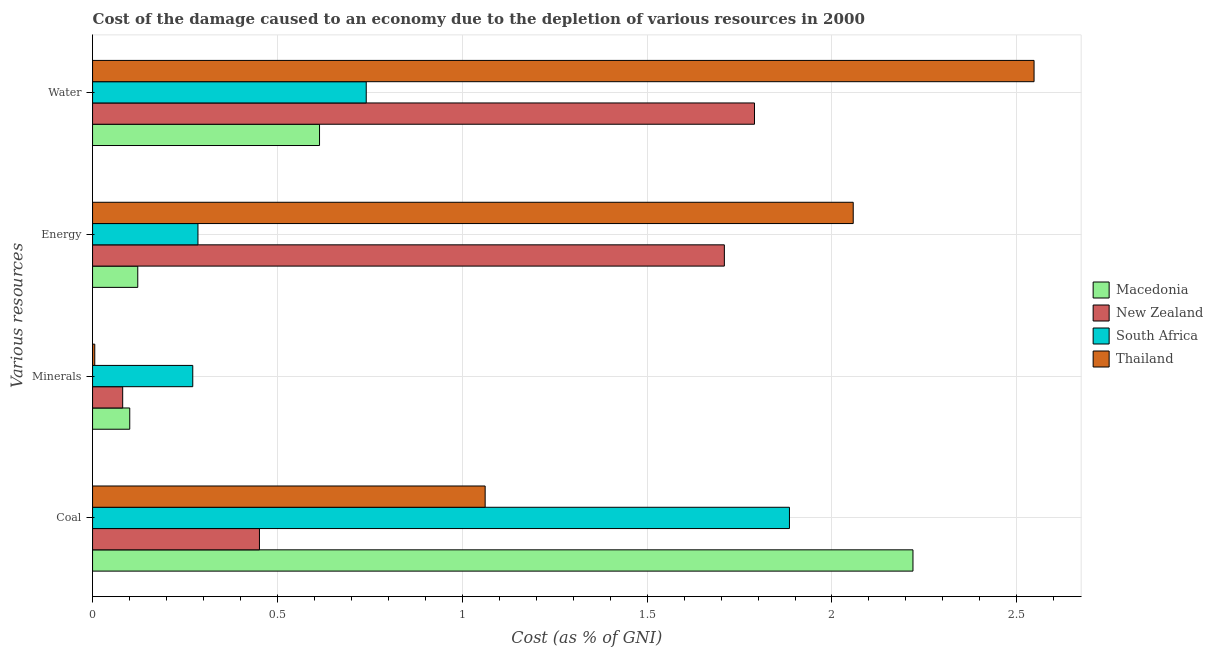Are the number of bars on each tick of the Y-axis equal?
Provide a succinct answer. Yes. How many bars are there on the 2nd tick from the bottom?
Provide a succinct answer. 4. What is the label of the 3rd group of bars from the top?
Give a very brief answer. Minerals. What is the cost of damage due to depletion of coal in New Zealand?
Keep it short and to the point. 0.45. Across all countries, what is the maximum cost of damage due to depletion of water?
Offer a terse response. 2.55. Across all countries, what is the minimum cost of damage due to depletion of energy?
Your response must be concise. 0.12. In which country was the cost of damage due to depletion of coal maximum?
Offer a terse response. Macedonia. In which country was the cost of damage due to depletion of water minimum?
Offer a very short reply. Macedonia. What is the total cost of damage due to depletion of coal in the graph?
Offer a very short reply. 5.62. What is the difference between the cost of damage due to depletion of minerals in Thailand and that in New Zealand?
Offer a very short reply. -0.08. What is the difference between the cost of damage due to depletion of coal in South Africa and the cost of damage due to depletion of energy in Macedonia?
Provide a succinct answer. 1.76. What is the average cost of damage due to depletion of water per country?
Ensure brevity in your answer.  1.42. What is the difference between the cost of damage due to depletion of minerals and cost of damage due to depletion of coal in Thailand?
Ensure brevity in your answer.  -1.06. What is the ratio of the cost of damage due to depletion of minerals in Thailand to that in South Africa?
Offer a terse response. 0.02. Is the cost of damage due to depletion of coal in South Africa less than that in New Zealand?
Provide a short and direct response. No. Is the difference between the cost of damage due to depletion of water in South Africa and Thailand greater than the difference between the cost of damage due to depletion of minerals in South Africa and Thailand?
Your response must be concise. No. What is the difference between the highest and the second highest cost of damage due to depletion of energy?
Offer a very short reply. 0.35. What is the difference between the highest and the lowest cost of damage due to depletion of water?
Offer a terse response. 1.93. In how many countries, is the cost of damage due to depletion of energy greater than the average cost of damage due to depletion of energy taken over all countries?
Offer a very short reply. 2. Is the sum of the cost of damage due to depletion of energy in South Africa and New Zealand greater than the maximum cost of damage due to depletion of minerals across all countries?
Offer a terse response. Yes. What does the 4th bar from the top in Minerals represents?
Give a very brief answer. Macedonia. What does the 4th bar from the bottom in Water represents?
Your answer should be compact. Thailand. Are all the bars in the graph horizontal?
Offer a terse response. Yes. How many countries are there in the graph?
Keep it short and to the point. 4. Are the values on the major ticks of X-axis written in scientific E-notation?
Your response must be concise. No. Does the graph contain grids?
Keep it short and to the point. Yes. How are the legend labels stacked?
Make the answer very short. Vertical. What is the title of the graph?
Your response must be concise. Cost of the damage caused to an economy due to the depletion of various resources in 2000 . What is the label or title of the X-axis?
Give a very brief answer. Cost (as % of GNI). What is the label or title of the Y-axis?
Your answer should be compact. Various resources. What is the Cost (as % of GNI) of Macedonia in Coal?
Ensure brevity in your answer.  2.22. What is the Cost (as % of GNI) of New Zealand in Coal?
Offer a terse response. 0.45. What is the Cost (as % of GNI) in South Africa in Coal?
Your response must be concise. 1.88. What is the Cost (as % of GNI) of Thailand in Coal?
Give a very brief answer. 1.06. What is the Cost (as % of GNI) in Macedonia in Minerals?
Your answer should be very brief. 0.1. What is the Cost (as % of GNI) of New Zealand in Minerals?
Make the answer very short. 0.08. What is the Cost (as % of GNI) in South Africa in Minerals?
Your answer should be very brief. 0.27. What is the Cost (as % of GNI) of Thailand in Minerals?
Give a very brief answer. 0.01. What is the Cost (as % of GNI) in Macedonia in Energy?
Ensure brevity in your answer.  0.12. What is the Cost (as % of GNI) of New Zealand in Energy?
Provide a short and direct response. 1.71. What is the Cost (as % of GNI) of South Africa in Energy?
Keep it short and to the point. 0.29. What is the Cost (as % of GNI) in Thailand in Energy?
Provide a short and direct response. 2.06. What is the Cost (as % of GNI) in Macedonia in Water?
Ensure brevity in your answer.  0.61. What is the Cost (as % of GNI) in New Zealand in Water?
Ensure brevity in your answer.  1.79. What is the Cost (as % of GNI) in South Africa in Water?
Provide a short and direct response. 0.74. What is the Cost (as % of GNI) in Thailand in Water?
Offer a very short reply. 2.55. Across all Various resources, what is the maximum Cost (as % of GNI) in Macedonia?
Provide a short and direct response. 2.22. Across all Various resources, what is the maximum Cost (as % of GNI) in New Zealand?
Make the answer very short. 1.79. Across all Various resources, what is the maximum Cost (as % of GNI) of South Africa?
Your answer should be compact. 1.88. Across all Various resources, what is the maximum Cost (as % of GNI) in Thailand?
Give a very brief answer. 2.55. Across all Various resources, what is the minimum Cost (as % of GNI) of Macedonia?
Give a very brief answer. 0.1. Across all Various resources, what is the minimum Cost (as % of GNI) of New Zealand?
Offer a terse response. 0.08. Across all Various resources, what is the minimum Cost (as % of GNI) of South Africa?
Keep it short and to the point. 0.27. Across all Various resources, what is the minimum Cost (as % of GNI) in Thailand?
Offer a terse response. 0.01. What is the total Cost (as % of GNI) of Macedonia in the graph?
Make the answer very short. 3.06. What is the total Cost (as % of GNI) of New Zealand in the graph?
Offer a terse response. 4.03. What is the total Cost (as % of GNI) of South Africa in the graph?
Keep it short and to the point. 3.18. What is the total Cost (as % of GNI) in Thailand in the graph?
Your answer should be compact. 5.67. What is the difference between the Cost (as % of GNI) of Macedonia in Coal and that in Minerals?
Your response must be concise. 2.12. What is the difference between the Cost (as % of GNI) of New Zealand in Coal and that in Minerals?
Give a very brief answer. 0.37. What is the difference between the Cost (as % of GNI) in South Africa in Coal and that in Minerals?
Your answer should be very brief. 1.61. What is the difference between the Cost (as % of GNI) in Thailand in Coal and that in Minerals?
Give a very brief answer. 1.06. What is the difference between the Cost (as % of GNI) in Macedonia in Coal and that in Energy?
Your answer should be very brief. 2.1. What is the difference between the Cost (as % of GNI) in New Zealand in Coal and that in Energy?
Offer a very short reply. -1.26. What is the difference between the Cost (as % of GNI) of South Africa in Coal and that in Energy?
Provide a short and direct response. 1.6. What is the difference between the Cost (as % of GNI) in Thailand in Coal and that in Energy?
Keep it short and to the point. -1. What is the difference between the Cost (as % of GNI) in Macedonia in Coal and that in Water?
Your answer should be compact. 1.61. What is the difference between the Cost (as % of GNI) in New Zealand in Coal and that in Water?
Offer a terse response. -1.34. What is the difference between the Cost (as % of GNI) in South Africa in Coal and that in Water?
Your response must be concise. 1.14. What is the difference between the Cost (as % of GNI) in Thailand in Coal and that in Water?
Offer a terse response. -1.48. What is the difference between the Cost (as % of GNI) of Macedonia in Minerals and that in Energy?
Your answer should be very brief. -0.02. What is the difference between the Cost (as % of GNI) in New Zealand in Minerals and that in Energy?
Offer a very short reply. -1.63. What is the difference between the Cost (as % of GNI) of South Africa in Minerals and that in Energy?
Ensure brevity in your answer.  -0.01. What is the difference between the Cost (as % of GNI) of Thailand in Minerals and that in Energy?
Your answer should be very brief. -2.05. What is the difference between the Cost (as % of GNI) in Macedonia in Minerals and that in Water?
Offer a very short reply. -0.51. What is the difference between the Cost (as % of GNI) in New Zealand in Minerals and that in Water?
Your answer should be compact. -1.71. What is the difference between the Cost (as % of GNI) of South Africa in Minerals and that in Water?
Offer a terse response. -0.47. What is the difference between the Cost (as % of GNI) in Thailand in Minerals and that in Water?
Offer a terse response. -2.54. What is the difference between the Cost (as % of GNI) of Macedonia in Energy and that in Water?
Offer a terse response. -0.49. What is the difference between the Cost (as % of GNI) in New Zealand in Energy and that in Water?
Offer a terse response. -0.08. What is the difference between the Cost (as % of GNI) in South Africa in Energy and that in Water?
Provide a short and direct response. -0.46. What is the difference between the Cost (as % of GNI) of Thailand in Energy and that in Water?
Make the answer very short. -0.49. What is the difference between the Cost (as % of GNI) in Macedonia in Coal and the Cost (as % of GNI) in New Zealand in Minerals?
Provide a succinct answer. 2.14. What is the difference between the Cost (as % of GNI) in Macedonia in Coal and the Cost (as % of GNI) in South Africa in Minerals?
Your answer should be very brief. 1.95. What is the difference between the Cost (as % of GNI) of Macedonia in Coal and the Cost (as % of GNI) of Thailand in Minerals?
Your answer should be compact. 2.21. What is the difference between the Cost (as % of GNI) in New Zealand in Coal and the Cost (as % of GNI) in South Africa in Minerals?
Offer a terse response. 0.18. What is the difference between the Cost (as % of GNI) in New Zealand in Coal and the Cost (as % of GNI) in Thailand in Minerals?
Your answer should be very brief. 0.45. What is the difference between the Cost (as % of GNI) of South Africa in Coal and the Cost (as % of GNI) of Thailand in Minerals?
Provide a short and direct response. 1.88. What is the difference between the Cost (as % of GNI) of Macedonia in Coal and the Cost (as % of GNI) of New Zealand in Energy?
Keep it short and to the point. 0.51. What is the difference between the Cost (as % of GNI) of Macedonia in Coal and the Cost (as % of GNI) of South Africa in Energy?
Make the answer very short. 1.93. What is the difference between the Cost (as % of GNI) in Macedonia in Coal and the Cost (as % of GNI) in Thailand in Energy?
Keep it short and to the point. 0.16. What is the difference between the Cost (as % of GNI) in New Zealand in Coal and the Cost (as % of GNI) in South Africa in Energy?
Give a very brief answer. 0.17. What is the difference between the Cost (as % of GNI) in New Zealand in Coal and the Cost (as % of GNI) in Thailand in Energy?
Make the answer very short. -1.61. What is the difference between the Cost (as % of GNI) of South Africa in Coal and the Cost (as % of GNI) of Thailand in Energy?
Offer a terse response. -0.17. What is the difference between the Cost (as % of GNI) in Macedonia in Coal and the Cost (as % of GNI) in New Zealand in Water?
Your answer should be compact. 0.43. What is the difference between the Cost (as % of GNI) in Macedonia in Coal and the Cost (as % of GNI) in South Africa in Water?
Ensure brevity in your answer.  1.48. What is the difference between the Cost (as % of GNI) in Macedonia in Coal and the Cost (as % of GNI) in Thailand in Water?
Your response must be concise. -0.33. What is the difference between the Cost (as % of GNI) of New Zealand in Coal and the Cost (as % of GNI) of South Africa in Water?
Provide a succinct answer. -0.29. What is the difference between the Cost (as % of GNI) in New Zealand in Coal and the Cost (as % of GNI) in Thailand in Water?
Your response must be concise. -2.1. What is the difference between the Cost (as % of GNI) in South Africa in Coal and the Cost (as % of GNI) in Thailand in Water?
Provide a short and direct response. -0.66. What is the difference between the Cost (as % of GNI) of Macedonia in Minerals and the Cost (as % of GNI) of New Zealand in Energy?
Your answer should be very brief. -1.61. What is the difference between the Cost (as % of GNI) of Macedonia in Minerals and the Cost (as % of GNI) of South Africa in Energy?
Offer a very short reply. -0.18. What is the difference between the Cost (as % of GNI) of Macedonia in Minerals and the Cost (as % of GNI) of Thailand in Energy?
Your response must be concise. -1.96. What is the difference between the Cost (as % of GNI) in New Zealand in Minerals and the Cost (as % of GNI) in South Africa in Energy?
Your response must be concise. -0.2. What is the difference between the Cost (as % of GNI) in New Zealand in Minerals and the Cost (as % of GNI) in Thailand in Energy?
Your answer should be compact. -1.98. What is the difference between the Cost (as % of GNI) of South Africa in Minerals and the Cost (as % of GNI) of Thailand in Energy?
Make the answer very short. -1.79. What is the difference between the Cost (as % of GNI) in Macedonia in Minerals and the Cost (as % of GNI) in New Zealand in Water?
Keep it short and to the point. -1.69. What is the difference between the Cost (as % of GNI) in Macedonia in Minerals and the Cost (as % of GNI) in South Africa in Water?
Keep it short and to the point. -0.64. What is the difference between the Cost (as % of GNI) of Macedonia in Minerals and the Cost (as % of GNI) of Thailand in Water?
Provide a short and direct response. -2.45. What is the difference between the Cost (as % of GNI) of New Zealand in Minerals and the Cost (as % of GNI) of South Africa in Water?
Keep it short and to the point. -0.66. What is the difference between the Cost (as % of GNI) of New Zealand in Minerals and the Cost (as % of GNI) of Thailand in Water?
Make the answer very short. -2.47. What is the difference between the Cost (as % of GNI) of South Africa in Minerals and the Cost (as % of GNI) of Thailand in Water?
Your response must be concise. -2.28. What is the difference between the Cost (as % of GNI) in Macedonia in Energy and the Cost (as % of GNI) in New Zealand in Water?
Offer a terse response. -1.67. What is the difference between the Cost (as % of GNI) of Macedonia in Energy and the Cost (as % of GNI) of South Africa in Water?
Provide a short and direct response. -0.62. What is the difference between the Cost (as % of GNI) of Macedonia in Energy and the Cost (as % of GNI) of Thailand in Water?
Your response must be concise. -2.42. What is the difference between the Cost (as % of GNI) in New Zealand in Energy and the Cost (as % of GNI) in South Africa in Water?
Offer a terse response. 0.97. What is the difference between the Cost (as % of GNI) in New Zealand in Energy and the Cost (as % of GNI) in Thailand in Water?
Your answer should be very brief. -0.84. What is the difference between the Cost (as % of GNI) of South Africa in Energy and the Cost (as % of GNI) of Thailand in Water?
Offer a terse response. -2.26. What is the average Cost (as % of GNI) in Macedonia per Various resources?
Your answer should be very brief. 0.76. What is the average Cost (as % of GNI) of New Zealand per Various resources?
Offer a terse response. 1.01. What is the average Cost (as % of GNI) of South Africa per Various resources?
Give a very brief answer. 0.8. What is the average Cost (as % of GNI) in Thailand per Various resources?
Ensure brevity in your answer.  1.42. What is the difference between the Cost (as % of GNI) in Macedonia and Cost (as % of GNI) in New Zealand in Coal?
Provide a short and direct response. 1.77. What is the difference between the Cost (as % of GNI) of Macedonia and Cost (as % of GNI) of South Africa in Coal?
Make the answer very short. 0.33. What is the difference between the Cost (as % of GNI) in Macedonia and Cost (as % of GNI) in Thailand in Coal?
Give a very brief answer. 1.16. What is the difference between the Cost (as % of GNI) in New Zealand and Cost (as % of GNI) in South Africa in Coal?
Make the answer very short. -1.43. What is the difference between the Cost (as % of GNI) of New Zealand and Cost (as % of GNI) of Thailand in Coal?
Give a very brief answer. -0.61. What is the difference between the Cost (as % of GNI) of South Africa and Cost (as % of GNI) of Thailand in Coal?
Offer a very short reply. 0.82. What is the difference between the Cost (as % of GNI) in Macedonia and Cost (as % of GNI) in New Zealand in Minerals?
Ensure brevity in your answer.  0.02. What is the difference between the Cost (as % of GNI) of Macedonia and Cost (as % of GNI) of South Africa in Minerals?
Offer a very short reply. -0.17. What is the difference between the Cost (as % of GNI) in Macedonia and Cost (as % of GNI) in Thailand in Minerals?
Give a very brief answer. 0.09. What is the difference between the Cost (as % of GNI) in New Zealand and Cost (as % of GNI) in South Africa in Minerals?
Make the answer very short. -0.19. What is the difference between the Cost (as % of GNI) of New Zealand and Cost (as % of GNI) of Thailand in Minerals?
Provide a short and direct response. 0.08. What is the difference between the Cost (as % of GNI) of South Africa and Cost (as % of GNI) of Thailand in Minerals?
Your answer should be very brief. 0.27. What is the difference between the Cost (as % of GNI) in Macedonia and Cost (as % of GNI) in New Zealand in Energy?
Provide a succinct answer. -1.59. What is the difference between the Cost (as % of GNI) in Macedonia and Cost (as % of GNI) in South Africa in Energy?
Your response must be concise. -0.16. What is the difference between the Cost (as % of GNI) of Macedonia and Cost (as % of GNI) of Thailand in Energy?
Your response must be concise. -1.94. What is the difference between the Cost (as % of GNI) in New Zealand and Cost (as % of GNI) in South Africa in Energy?
Keep it short and to the point. 1.42. What is the difference between the Cost (as % of GNI) in New Zealand and Cost (as % of GNI) in Thailand in Energy?
Provide a succinct answer. -0.35. What is the difference between the Cost (as % of GNI) of South Africa and Cost (as % of GNI) of Thailand in Energy?
Keep it short and to the point. -1.77. What is the difference between the Cost (as % of GNI) in Macedonia and Cost (as % of GNI) in New Zealand in Water?
Your answer should be very brief. -1.18. What is the difference between the Cost (as % of GNI) of Macedonia and Cost (as % of GNI) of South Africa in Water?
Your answer should be compact. -0.13. What is the difference between the Cost (as % of GNI) in Macedonia and Cost (as % of GNI) in Thailand in Water?
Offer a terse response. -1.93. What is the difference between the Cost (as % of GNI) in New Zealand and Cost (as % of GNI) in South Africa in Water?
Provide a short and direct response. 1.05. What is the difference between the Cost (as % of GNI) of New Zealand and Cost (as % of GNI) of Thailand in Water?
Your answer should be compact. -0.76. What is the difference between the Cost (as % of GNI) of South Africa and Cost (as % of GNI) of Thailand in Water?
Provide a short and direct response. -1.81. What is the ratio of the Cost (as % of GNI) of Macedonia in Coal to that in Minerals?
Give a very brief answer. 22.06. What is the ratio of the Cost (as % of GNI) of New Zealand in Coal to that in Minerals?
Your answer should be very brief. 5.54. What is the ratio of the Cost (as % of GNI) in South Africa in Coal to that in Minerals?
Your response must be concise. 6.95. What is the ratio of the Cost (as % of GNI) of Thailand in Coal to that in Minerals?
Offer a very short reply. 178.73. What is the ratio of the Cost (as % of GNI) in Macedonia in Coal to that in Energy?
Your response must be concise. 18.15. What is the ratio of the Cost (as % of GNI) in New Zealand in Coal to that in Energy?
Offer a very short reply. 0.26. What is the ratio of the Cost (as % of GNI) in South Africa in Coal to that in Energy?
Give a very brief answer. 6.61. What is the ratio of the Cost (as % of GNI) in Thailand in Coal to that in Energy?
Make the answer very short. 0.52. What is the ratio of the Cost (as % of GNI) of Macedonia in Coal to that in Water?
Your response must be concise. 3.61. What is the ratio of the Cost (as % of GNI) in New Zealand in Coal to that in Water?
Ensure brevity in your answer.  0.25. What is the ratio of the Cost (as % of GNI) of South Africa in Coal to that in Water?
Ensure brevity in your answer.  2.55. What is the ratio of the Cost (as % of GNI) of Thailand in Coal to that in Water?
Ensure brevity in your answer.  0.42. What is the ratio of the Cost (as % of GNI) of Macedonia in Minerals to that in Energy?
Provide a short and direct response. 0.82. What is the ratio of the Cost (as % of GNI) in New Zealand in Minerals to that in Energy?
Give a very brief answer. 0.05. What is the ratio of the Cost (as % of GNI) of South Africa in Minerals to that in Energy?
Your answer should be very brief. 0.95. What is the ratio of the Cost (as % of GNI) of Thailand in Minerals to that in Energy?
Your response must be concise. 0. What is the ratio of the Cost (as % of GNI) of Macedonia in Minerals to that in Water?
Provide a short and direct response. 0.16. What is the ratio of the Cost (as % of GNI) of New Zealand in Minerals to that in Water?
Your answer should be compact. 0.05. What is the ratio of the Cost (as % of GNI) of South Africa in Minerals to that in Water?
Your answer should be compact. 0.37. What is the ratio of the Cost (as % of GNI) of Thailand in Minerals to that in Water?
Offer a terse response. 0. What is the ratio of the Cost (as % of GNI) in Macedonia in Energy to that in Water?
Keep it short and to the point. 0.2. What is the ratio of the Cost (as % of GNI) in New Zealand in Energy to that in Water?
Offer a very short reply. 0.95. What is the ratio of the Cost (as % of GNI) of South Africa in Energy to that in Water?
Give a very brief answer. 0.39. What is the ratio of the Cost (as % of GNI) of Thailand in Energy to that in Water?
Provide a short and direct response. 0.81. What is the difference between the highest and the second highest Cost (as % of GNI) in Macedonia?
Ensure brevity in your answer.  1.61. What is the difference between the highest and the second highest Cost (as % of GNI) in New Zealand?
Your answer should be compact. 0.08. What is the difference between the highest and the second highest Cost (as % of GNI) of South Africa?
Make the answer very short. 1.14. What is the difference between the highest and the second highest Cost (as % of GNI) of Thailand?
Offer a terse response. 0.49. What is the difference between the highest and the lowest Cost (as % of GNI) of Macedonia?
Give a very brief answer. 2.12. What is the difference between the highest and the lowest Cost (as % of GNI) of New Zealand?
Provide a succinct answer. 1.71. What is the difference between the highest and the lowest Cost (as % of GNI) of South Africa?
Ensure brevity in your answer.  1.61. What is the difference between the highest and the lowest Cost (as % of GNI) in Thailand?
Give a very brief answer. 2.54. 